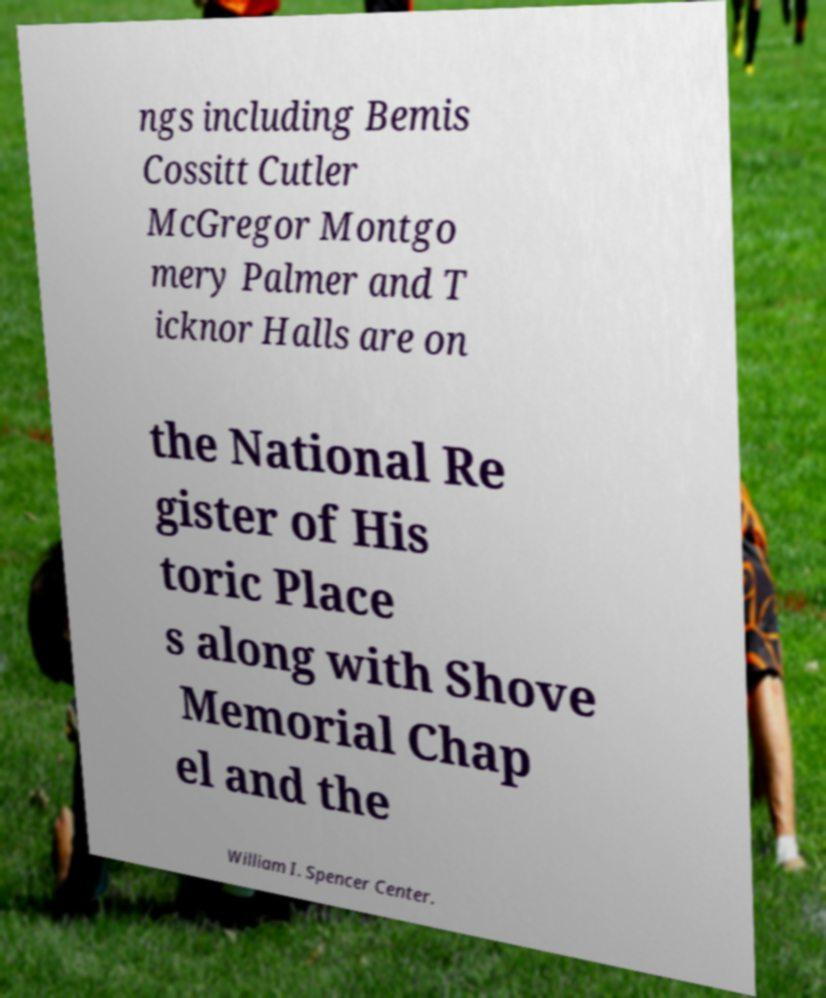Please read and relay the text visible in this image. What does it say? ngs including Bemis Cossitt Cutler McGregor Montgo mery Palmer and T icknor Halls are on the National Re gister of His toric Place s along with Shove Memorial Chap el and the William I. Spencer Center. 